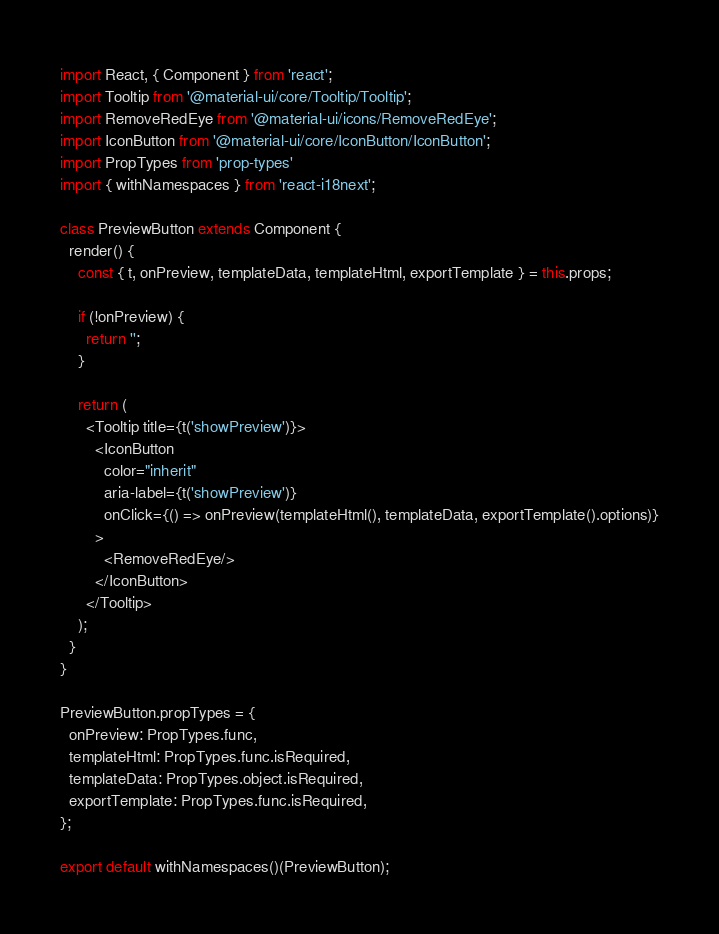Convert code to text. <code><loc_0><loc_0><loc_500><loc_500><_JavaScript_>import React, { Component } from 'react';
import Tooltip from '@material-ui/core/Tooltip/Tooltip';
import RemoveRedEye from '@material-ui/icons/RemoveRedEye';
import IconButton from '@material-ui/core/IconButton/IconButton';
import PropTypes from 'prop-types'
import { withNamespaces } from 'react-i18next';

class PreviewButton extends Component {
  render() {
    const { t, onPreview, templateData, templateHtml, exportTemplate } = this.props;

    if (!onPreview) {
      return '';
    }

    return (
      <Tooltip title={t('showPreview')}>
        <IconButton
          color="inherit"
          aria-label={t('showPreview')}
          onClick={() => onPreview(templateHtml(), templateData, exportTemplate().options)}
        >
          <RemoveRedEye/>
        </IconButton>
      </Tooltip>
    );
  }
}

PreviewButton.propTypes = {
  onPreview: PropTypes.func,
  templateHtml: PropTypes.func.isRequired,
  templateData: PropTypes.object.isRequired,
  exportTemplate: PropTypes.func.isRequired,
};

export default withNamespaces()(PreviewButton);
</code> 